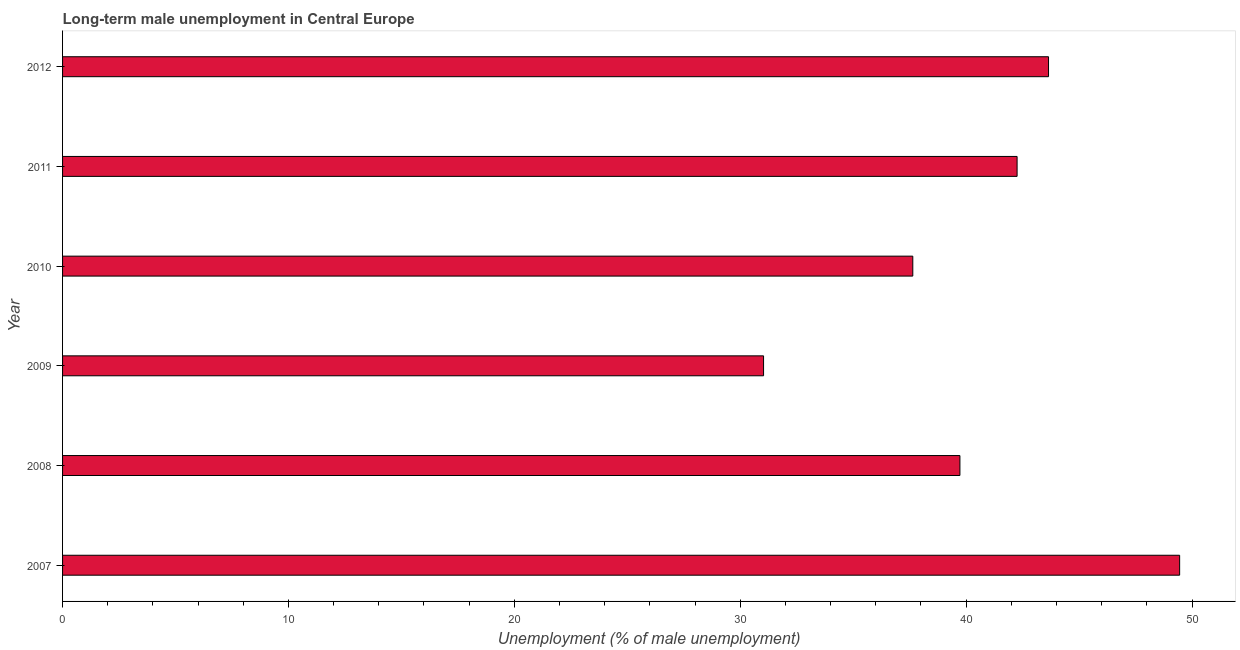What is the title of the graph?
Keep it short and to the point. Long-term male unemployment in Central Europe. What is the label or title of the X-axis?
Your response must be concise. Unemployment (% of male unemployment). What is the long-term male unemployment in 2010?
Offer a very short reply. 37.64. Across all years, what is the maximum long-term male unemployment?
Offer a very short reply. 49.45. Across all years, what is the minimum long-term male unemployment?
Offer a terse response. 31.03. In which year was the long-term male unemployment minimum?
Offer a very short reply. 2009. What is the sum of the long-term male unemployment?
Your response must be concise. 243.76. What is the difference between the long-term male unemployment in 2008 and 2011?
Provide a succinct answer. -2.53. What is the average long-term male unemployment per year?
Your response must be concise. 40.63. What is the median long-term male unemployment?
Offer a very short reply. 40.99. What is the ratio of the long-term male unemployment in 2010 to that in 2011?
Your response must be concise. 0.89. Is the difference between the long-term male unemployment in 2007 and 2009 greater than the difference between any two years?
Give a very brief answer. Yes. What is the difference between the highest and the second highest long-term male unemployment?
Keep it short and to the point. 5.8. Is the sum of the long-term male unemployment in 2009 and 2010 greater than the maximum long-term male unemployment across all years?
Give a very brief answer. Yes. What is the difference between the highest and the lowest long-term male unemployment?
Your answer should be very brief. 18.42. How many bars are there?
Keep it short and to the point. 6. Are all the bars in the graph horizontal?
Your answer should be very brief. Yes. How many years are there in the graph?
Your response must be concise. 6. What is the difference between two consecutive major ticks on the X-axis?
Offer a very short reply. 10. Are the values on the major ticks of X-axis written in scientific E-notation?
Ensure brevity in your answer.  No. What is the Unemployment (% of male unemployment) in 2007?
Ensure brevity in your answer.  49.45. What is the Unemployment (% of male unemployment) of 2008?
Give a very brief answer. 39.73. What is the Unemployment (% of male unemployment) of 2009?
Your response must be concise. 31.03. What is the Unemployment (% of male unemployment) in 2010?
Provide a short and direct response. 37.64. What is the Unemployment (% of male unemployment) in 2011?
Provide a succinct answer. 42.26. What is the Unemployment (% of male unemployment) of 2012?
Give a very brief answer. 43.65. What is the difference between the Unemployment (% of male unemployment) in 2007 and 2008?
Your response must be concise. 9.73. What is the difference between the Unemployment (% of male unemployment) in 2007 and 2009?
Keep it short and to the point. 18.42. What is the difference between the Unemployment (% of male unemployment) in 2007 and 2010?
Provide a short and direct response. 11.81. What is the difference between the Unemployment (% of male unemployment) in 2007 and 2011?
Keep it short and to the point. 7.2. What is the difference between the Unemployment (% of male unemployment) in 2007 and 2012?
Offer a very short reply. 5.8. What is the difference between the Unemployment (% of male unemployment) in 2008 and 2009?
Make the answer very short. 8.69. What is the difference between the Unemployment (% of male unemployment) in 2008 and 2010?
Your answer should be very brief. 2.09. What is the difference between the Unemployment (% of male unemployment) in 2008 and 2011?
Keep it short and to the point. -2.53. What is the difference between the Unemployment (% of male unemployment) in 2008 and 2012?
Your response must be concise. -3.92. What is the difference between the Unemployment (% of male unemployment) in 2009 and 2010?
Provide a succinct answer. -6.61. What is the difference between the Unemployment (% of male unemployment) in 2009 and 2011?
Give a very brief answer. -11.22. What is the difference between the Unemployment (% of male unemployment) in 2009 and 2012?
Provide a short and direct response. -12.62. What is the difference between the Unemployment (% of male unemployment) in 2010 and 2011?
Make the answer very short. -4.62. What is the difference between the Unemployment (% of male unemployment) in 2010 and 2012?
Offer a very short reply. -6.01. What is the difference between the Unemployment (% of male unemployment) in 2011 and 2012?
Ensure brevity in your answer.  -1.39. What is the ratio of the Unemployment (% of male unemployment) in 2007 to that in 2008?
Provide a short and direct response. 1.25. What is the ratio of the Unemployment (% of male unemployment) in 2007 to that in 2009?
Offer a very short reply. 1.59. What is the ratio of the Unemployment (% of male unemployment) in 2007 to that in 2010?
Offer a very short reply. 1.31. What is the ratio of the Unemployment (% of male unemployment) in 2007 to that in 2011?
Make the answer very short. 1.17. What is the ratio of the Unemployment (% of male unemployment) in 2007 to that in 2012?
Your answer should be compact. 1.13. What is the ratio of the Unemployment (% of male unemployment) in 2008 to that in 2009?
Give a very brief answer. 1.28. What is the ratio of the Unemployment (% of male unemployment) in 2008 to that in 2010?
Offer a very short reply. 1.05. What is the ratio of the Unemployment (% of male unemployment) in 2008 to that in 2011?
Your answer should be very brief. 0.94. What is the ratio of the Unemployment (% of male unemployment) in 2008 to that in 2012?
Your answer should be compact. 0.91. What is the ratio of the Unemployment (% of male unemployment) in 2009 to that in 2010?
Offer a terse response. 0.82. What is the ratio of the Unemployment (% of male unemployment) in 2009 to that in 2011?
Make the answer very short. 0.73. What is the ratio of the Unemployment (% of male unemployment) in 2009 to that in 2012?
Give a very brief answer. 0.71. What is the ratio of the Unemployment (% of male unemployment) in 2010 to that in 2011?
Make the answer very short. 0.89. What is the ratio of the Unemployment (% of male unemployment) in 2010 to that in 2012?
Your answer should be very brief. 0.86. What is the ratio of the Unemployment (% of male unemployment) in 2011 to that in 2012?
Your answer should be compact. 0.97. 